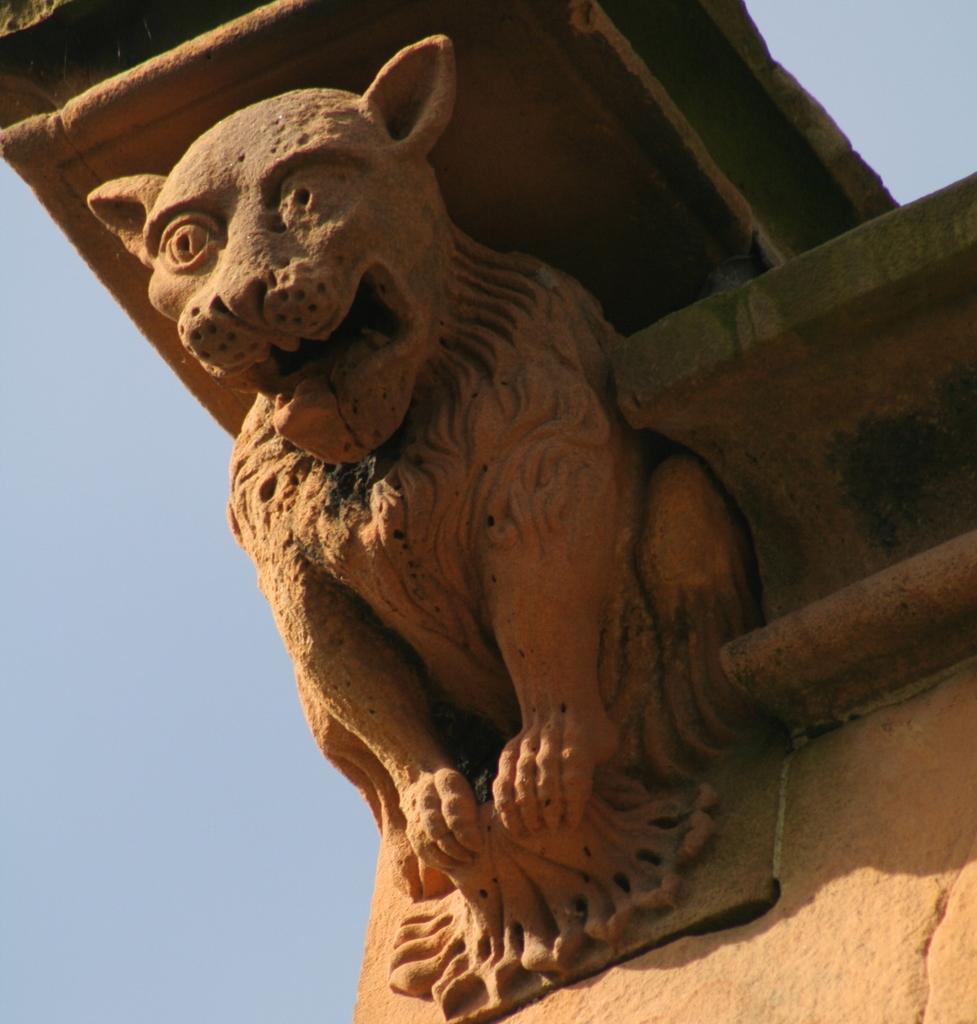Please provide a concise description of this image. In this image I can see the statue of an animal, background the sky is in blue color. 